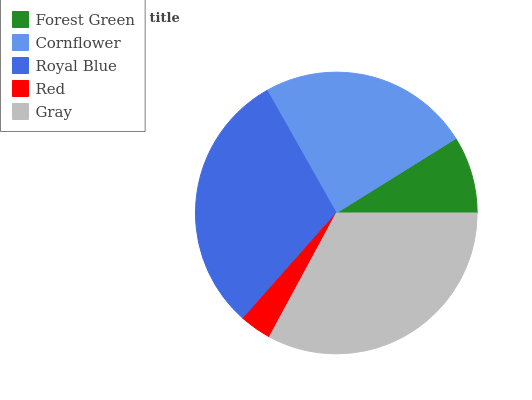Is Red the minimum?
Answer yes or no. Yes. Is Gray the maximum?
Answer yes or no. Yes. Is Cornflower the minimum?
Answer yes or no. No. Is Cornflower the maximum?
Answer yes or no. No. Is Cornflower greater than Forest Green?
Answer yes or no. Yes. Is Forest Green less than Cornflower?
Answer yes or no. Yes. Is Forest Green greater than Cornflower?
Answer yes or no. No. Is Cornflower less than Forest Green?
Answer yes or no. No. Is Cornflower the high median?
Answer yes or no. Yes. Is Cornflower the low median?
Answer yes or no. Yes. Is Forest Green the high median?
Answer yes or no. No. Is Gray the low median?
Answer yes or no. No. 